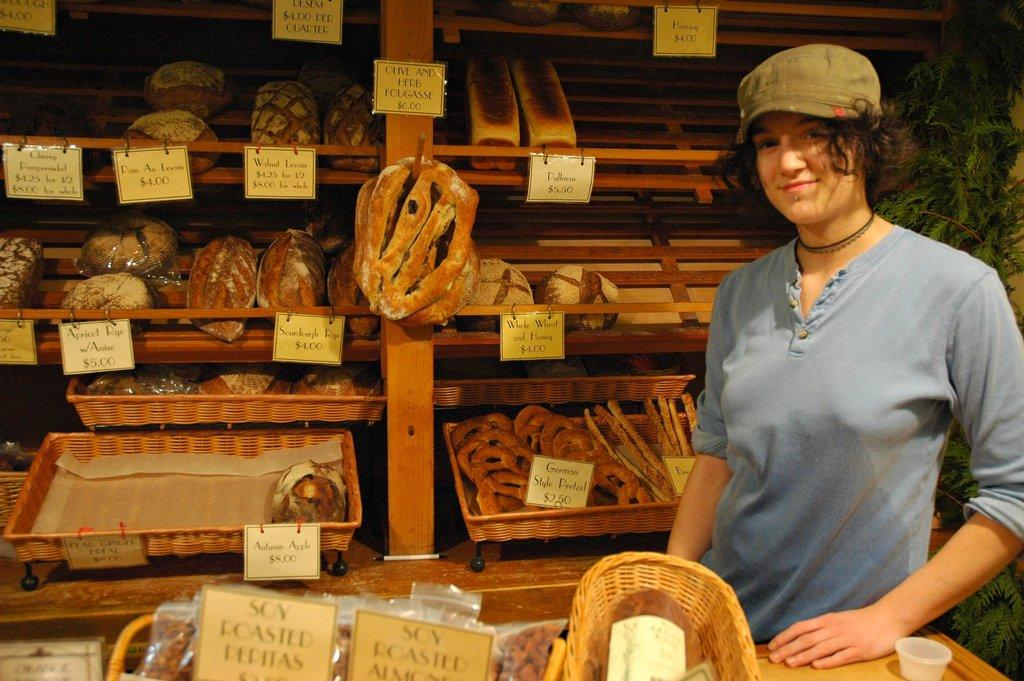Provide a one-sentence caption for the provided image. A woman at a stand selling things like German Style Pretzels for $2.50. 